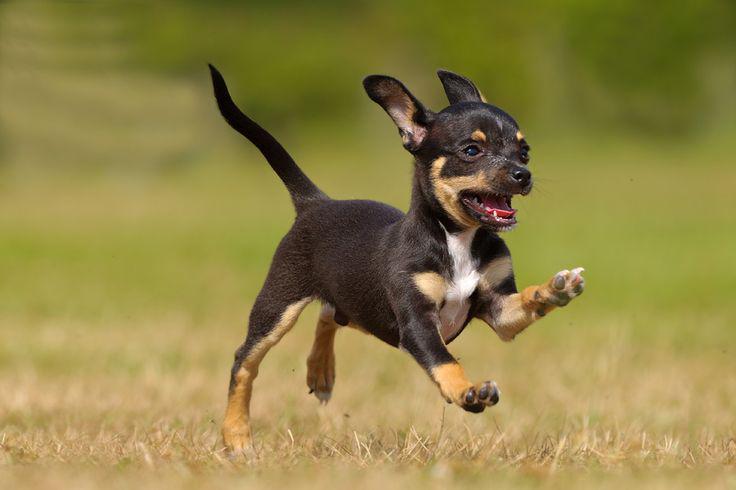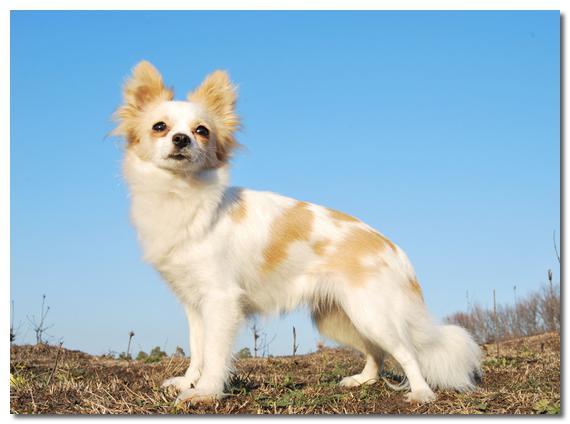The first image is the image on the left, the second image is the image on the right. For the images displayed, is the sentence "there is a mostly black dog leaping through the air in the image on the left" factually correct? Answer yes or no. Yes. The first image is the image on the left, the second image is the image on the right. For the images shown, is this caption "All dogs in the images are running across the grass." true? Answer yes or no. No. 